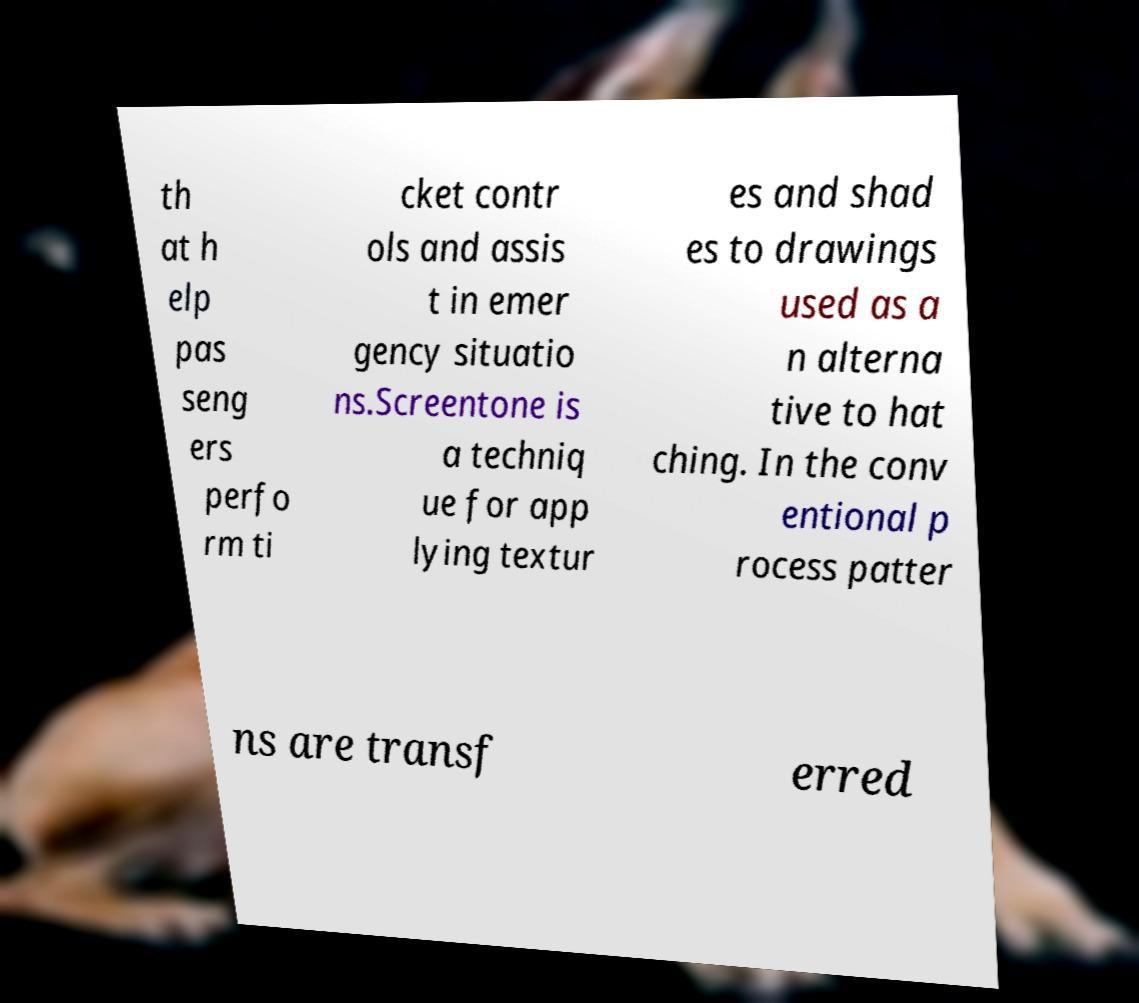Please identify and transcribe the text found in this image. th at h elp pas seng ers perfo rm ti cket contr ols and assis t in emer gency situatio ns.Screentone is a techniq ue for app lying textur es and shad es to drawings used as a n alterna tive to hat ching. In the conv entional p rocess patter ns are transf erred 